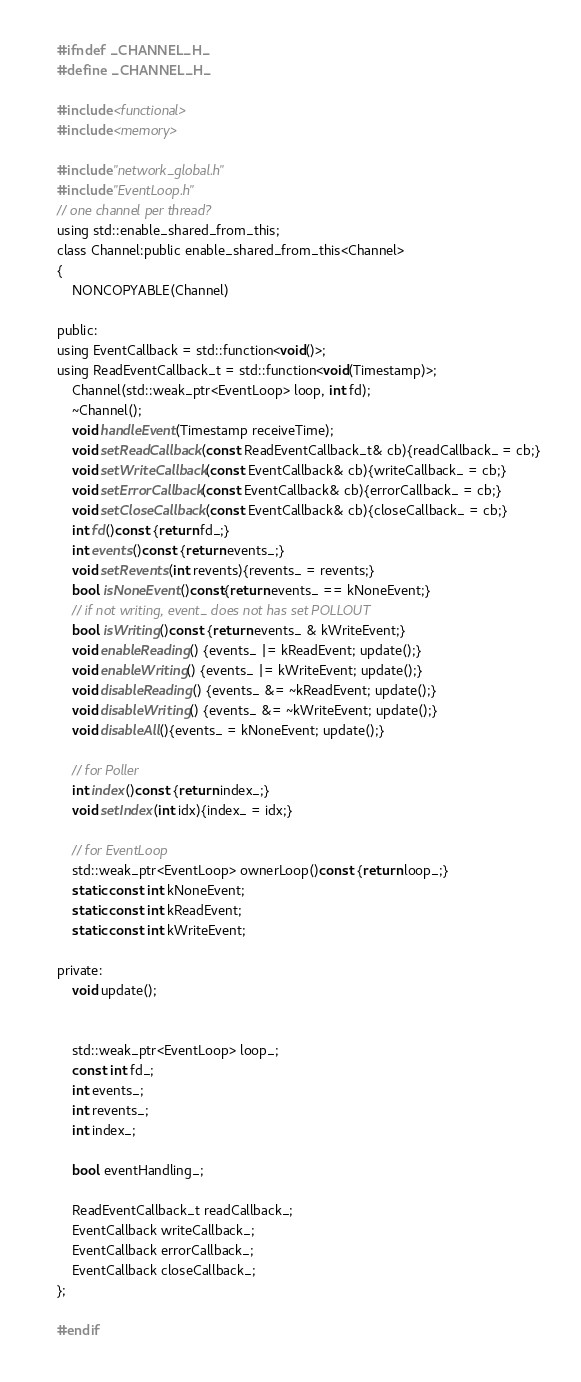Convert code to text. <code><loc_0><loc_0><loc_500><loc_500><_C_>#ifndef _CHANNEL_H_
#define _CHANNEL_H_

#include <functional>
#include <memory>

#include "network_global.h"
#include "EventLoop.h"
// one channel per thread?
using std::enable_shared_from_this;
class Channel:public enable_shared_from_this<Channel>
{
    NONCOPYABLE(Channel)

public:
using EventCallback = std::function<void()>;
using ReadEventCallback_t = std::function<void(Timestamp)>;
    Channel(std::weak_ptr<EventLoop> loop, int fd);
    ~Channel();
    void handleEvent(Timestamp receiveTime);
    void setReadCallback(const ReadEventCallback_t& cb){readCallback_ = cb;}
    void setWriteCallback(const EventCallback& cb){writeCallback_ = cb;}
    void setErrorCallback(const EventCallback& cb){errorCallback_ = cb;}
    void setCloseCallback(const EventCallback& cb){closeCallback_ = cb;}
    int fd()const {return fd_;}
    int events()const {return events_;}
    void setRevents(int revents){revents_ = revents;}
    bool isNoneEvent()const{return events_ == kNoneEvent;}
    // if not writing, event_ does not has set POLLOUT
    bool isWriting()const {return events_ & kWriteEvent;}
    void enableReading() {events_ |= kReadEvent; update();}
    void enableWriting() {events_ |= kWriteEvent; update();}
    void disableReading() {events_ &= ~kReadEvent; update();}
    void disableWriting() {events_ &= ~kWriteEvent; update();}
    void disableAll(){events_ = kNoneEvent; update();}

    // for Poller
    int index()const {return index_;}
    void setIndex(int idx){index_ = idx;}

    // for EventLoop
    std::weak_ptr<EventLoop> ownerLoop()const {return loop_;}
    static const int kNoneEvent;
    static const int kReadEvent;
    static const int kWriteEvent;

private:
    void update();


    std::weak_ptr<EventLoop> loop_;
    const int fd_;
    int events_;
    int revents_;
    int index_;

    bool eventHandling_;

    ReadEventCallback_t readCallback_;
    EventCallback writeCallback_;
    EventCallback errorCallback_;
    EventCallback closeCallback_;
};

#endif</code> 